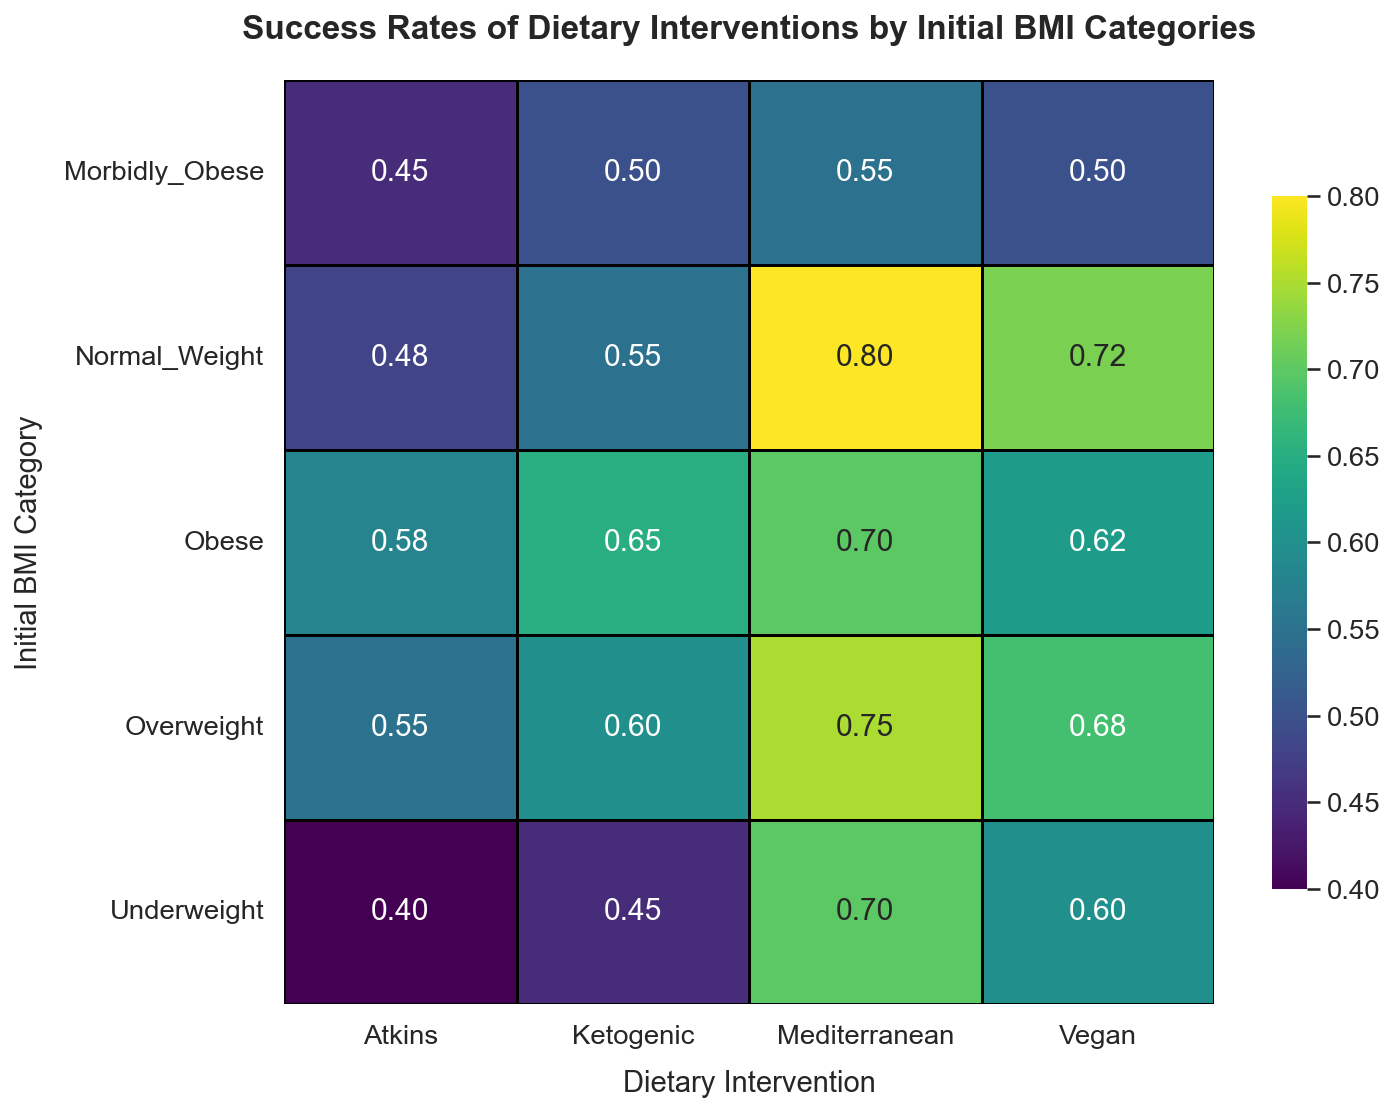Which dietary intervention has the highest success rate for the underweight category? By examining the Underweight row, we can see the success rates for Ketogenic, Atkins, Mediterranean, and Vegan diets. The Mediterranean diet has the highest success rate.
Answer: Mediterranean Which Initial BMI Category has the highest success rate for the Mediterranean diet? By examining the Mediterranean column, we can see the success rates for Underweight, Normal Weight, Overweight, Obese, and Morbidly Obese categories. The Normal Weight category has the highest success rate.
Answer: Normal Weight Which dietary intervention has the lowest success rate for the obese category? By looking at the Obese row, we can see the success rates for Ketogenic, Atkins, Mediterranean, and Vegan diets. The Atkins diet has the lowest success rate.
Answer: Atkins Compare the success rates of the vegan diet between Underweight and Overweight categories. By examining the Vegan column, the success rates for Underweight and Overweight categories are given as 0.60 and 0.68 respectively. The Overweight category has a higher success rate.
Answer: Overweight What is the average success rate of the Mediterranean diet across all BMI categories? To find the average, sum the success rates for the Mediterranean diet across all Initial BMI Categories (0.70 + 0.80 + 0.75 + 0.70 + 0.55) then divide by the number of categories. The total sum is 3.50, and there are 5 categories, so the average is 3.50/5 = 0.70.
Answer: 0.70 What is the difference in success rate between the Ketogenic diet for the Normal Weight and Morbidly Obese categories? Comparing the Ketogenic success rate of Normal Weight (0.55) and Morbidly Obese (0.50) categories, the difference is 0.55 - 0.50 = 0.05.
Answer: 0.05 Among all BMI categories, which dietary intervention displays the least variation in success rates? By scanning the success rates for each intervention across all BMI categories, it is clear that Mediterranean diet success rates range from 0.55 to 0.80, Ketogenic from 0.45 to 0.65, Atkins from 0.40 to 0.58, and Vegan from 0.50 to 0.72. The Atkins diet shows the least variation (0.58 - 0.40 = 0.18).
Answer: Atkins What is the total sum of success rates for the Vegan diet across all BMI categories? To find the sum, add the Vegan success rates across all BMI categories (0.60 + 0.72 + 0.68 + 0.62 + 0.50). The total sum is 0.60 + 0.72 + 0.68 + 0.62 + 0.50 = 3.12.
Answer: 3.12 Which two dietary interventions have the closest success rates for the Morbidly Obese category? By focusing on the Morbidly Obese row, we can see success rates for Ketogenic (0.50), Atkins (0.45), Mediterranean (0.55), and Vegan (0.50). The Ketogenic and Vegan diets have the closest success rates (both 0.50).
Answer: Ketogenic and Vegan How does the success rate of the Atkins diet for the Overweight category compare to that of the Mediterranean diet for the same category? The success rate of the Atkins diet for the Overweight category is 0.55, while for the Mediterranean diet in the same category it is 0.75. The Mediterranean diet has a higher success rate.
Answer: Mediterranean 